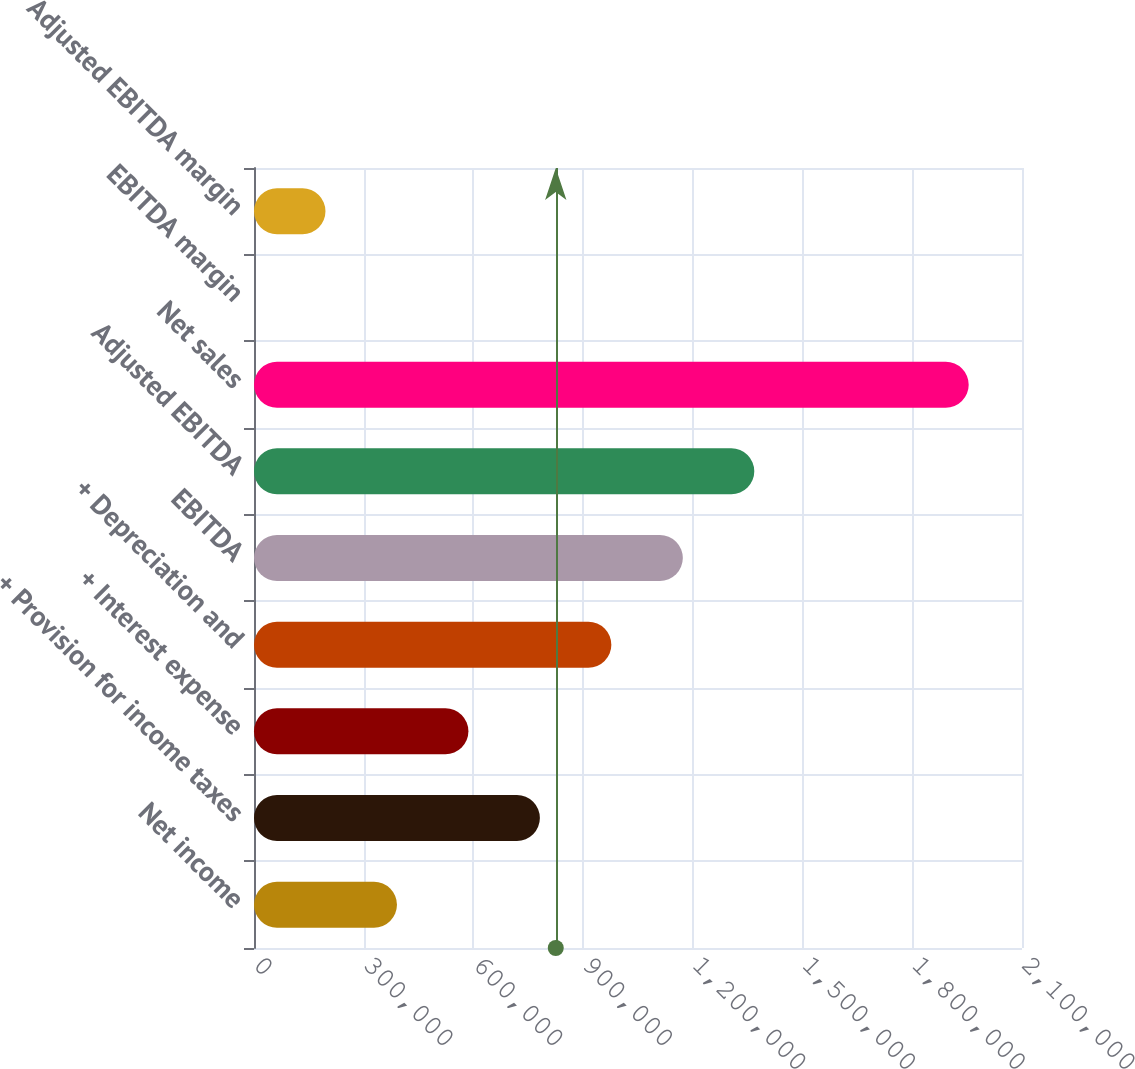Convert chart. <chart><loc_0><loc_0><loc_500><loc_500><bar_chart><fcel>Net income<fcel>+ Provision for income taxes<fcel>+ Interest expense<fcel>+ Depreciation and<fcel>EBITDA<fcel>Adjusted EBITDA<fcel>Net sales<fcel>EBITDA margin<fcel>Adjusted EBITDA margin<nl><fcel>390860<fcel>781710<fcel>586285<fcel>977134<fcel>1.17256e+06<fcel>1.36798e+06<fcel>1.95426e+06<fcel>10.6<fcel>195435<nl></chart> 